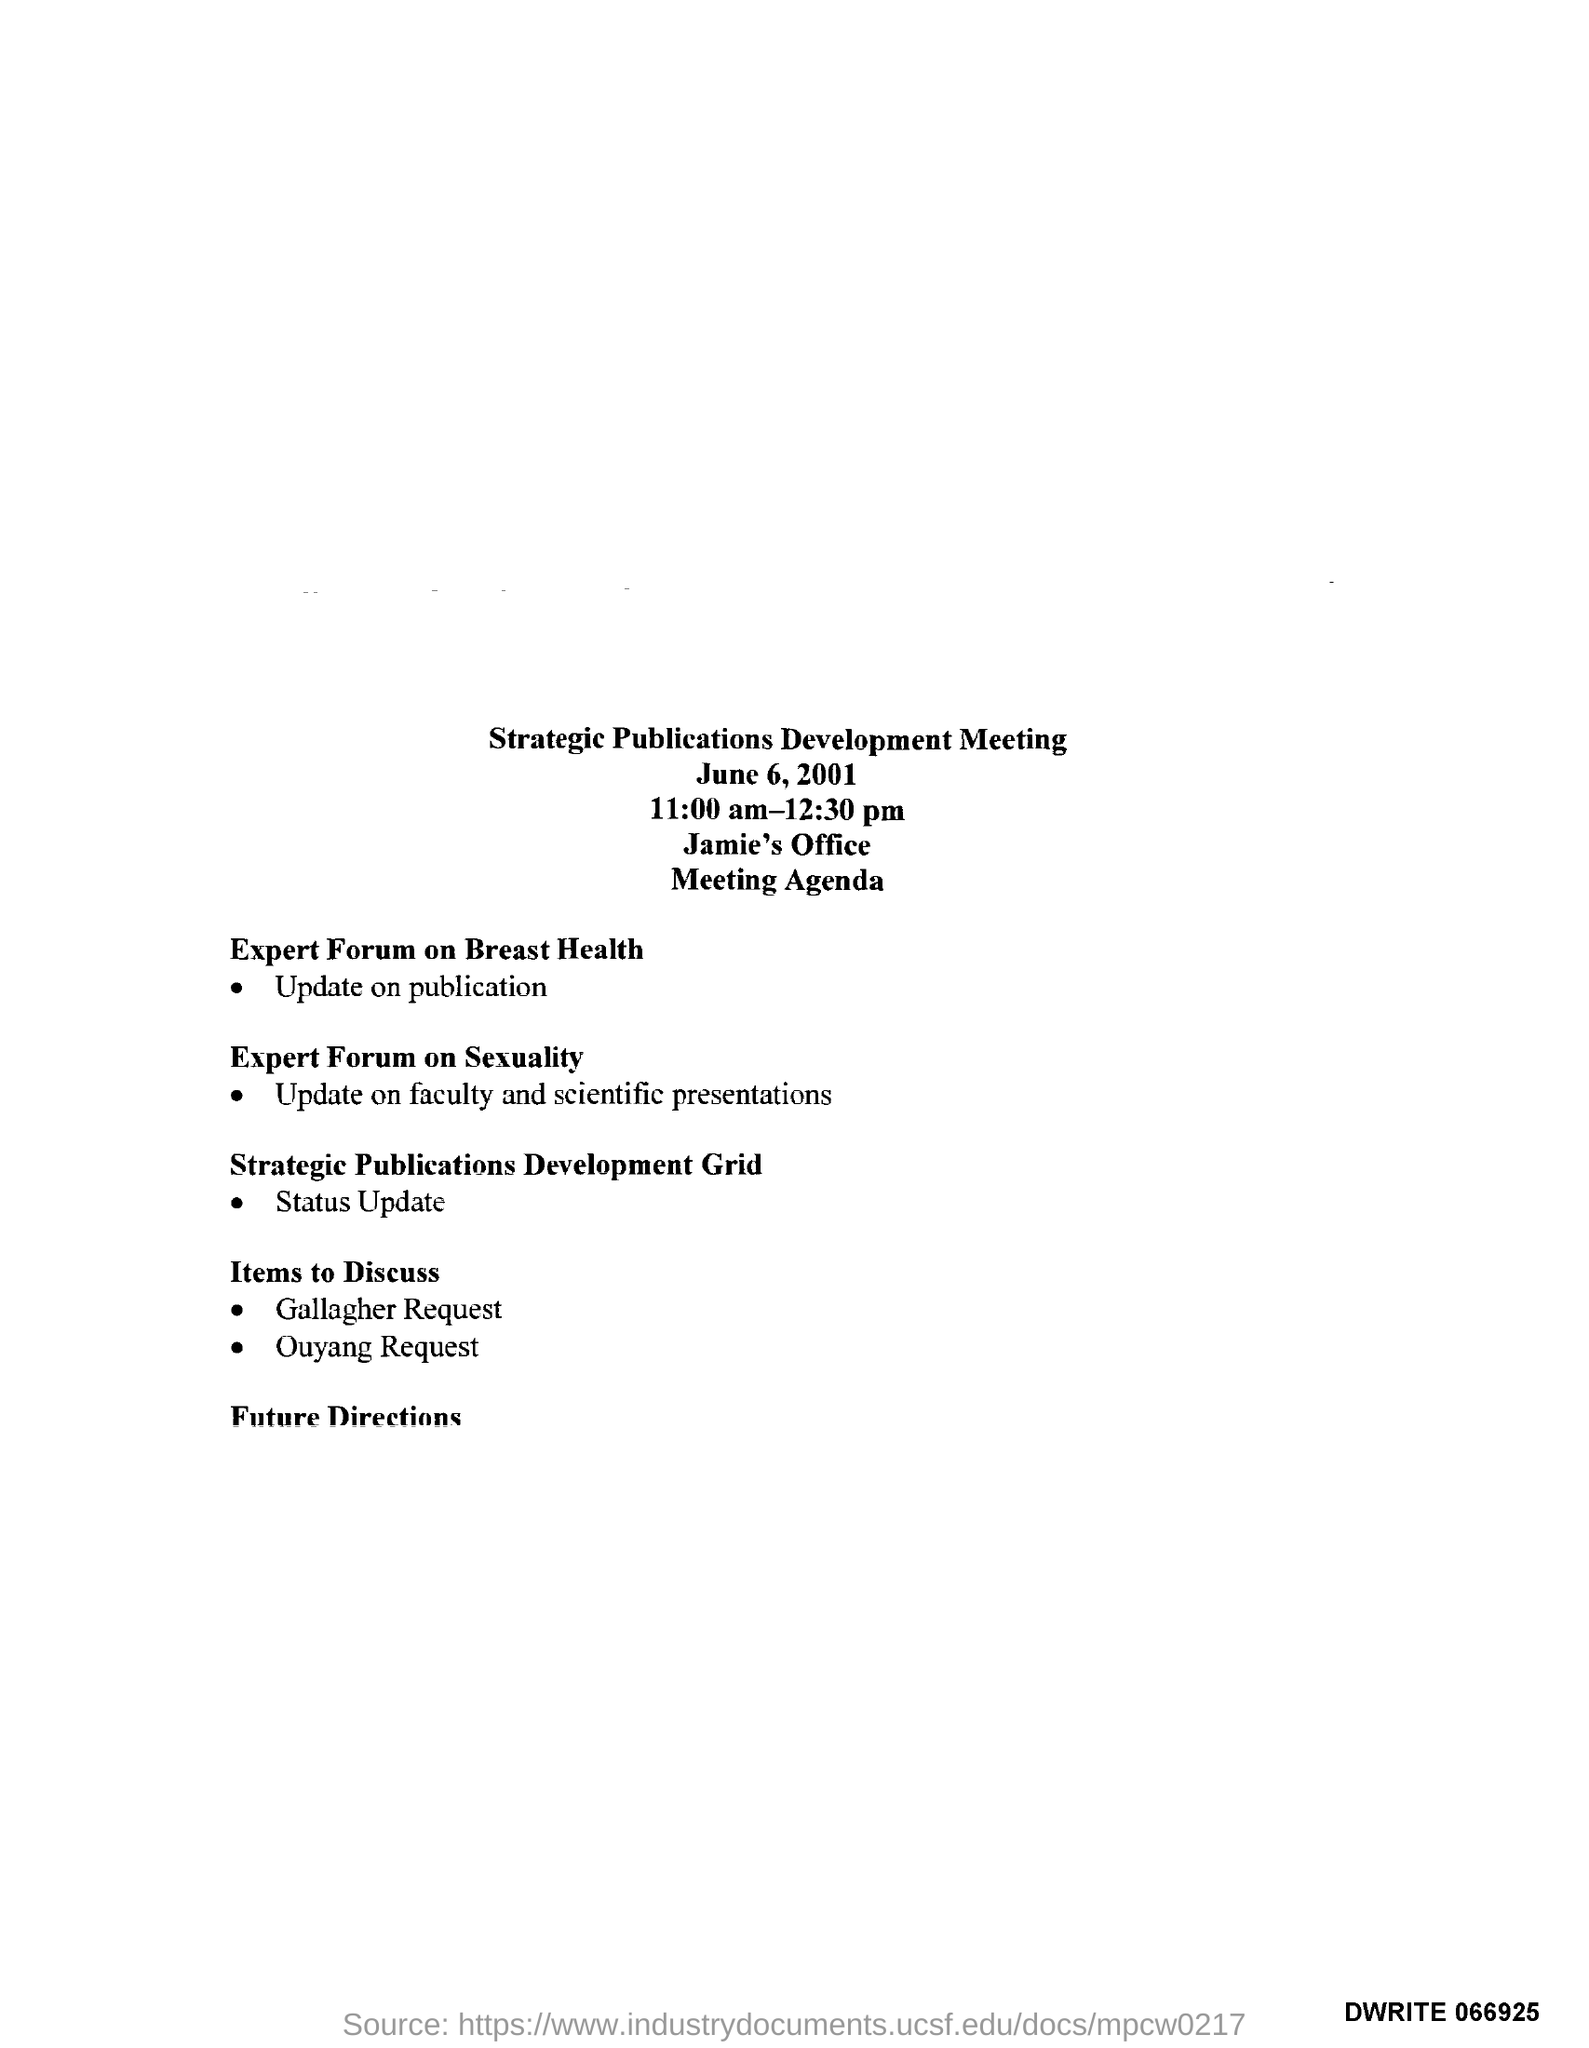What is the title?
Your answer should be compact. STRATEGIC PUBLICATION DEVELOPMENT MEETING. When was the meeting held?
Your answer should be compact. JUNE 6, 2001. What was the meeting timings?
Provide a succinct answer. 11:00 am-12:30 pm. Where was the meeting held?
Your answer should be compact. JAMIE'S OFFICE. What is the first main agenda?
Ensure brevity in your answer.  EXPERT FORUM ON BREAST HEALTH. 